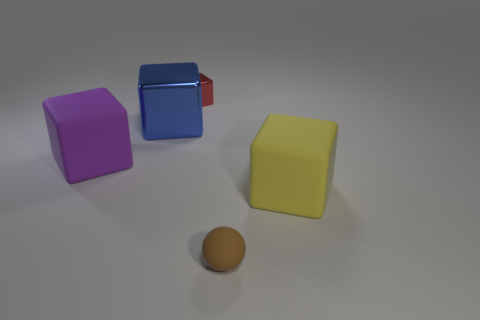Is the purple object made of the same material as the small red cube?
Make the answer very short. No. Are there fewer tiny brown rubber objects than big brown rubber cylinders?
Offer a very short reply. No. Is the big blue object the same shape as the tiny brown object?
Provide a short and direct response. No. The big metal cube has what color?
Give a very brief answer. Blue. What number of other things are made of the same material as the tiny red block?
Give a very brief answer. 1. What number of gray objects are tiny spheres or metallic cubes?
Your answer should be very brief. 0. There is a large rubber thing left of the big blue metallic block; is its shape the same as the big object that is on the right side of the blue thing?
Offer a terse response. Yes. There is a small object that is behind the big yellow block; does it have the same color as the ball?
Ensure brevity in your answer.  No. What number of things are blue objects or shiny blocks that are left of the red object?
Your response must be concise. 1. What material is the thing that is on the right side of the large blue shiny cube and left of the ball?
Make the answer very short. Metal. 